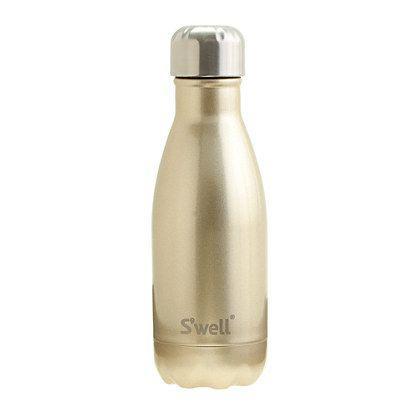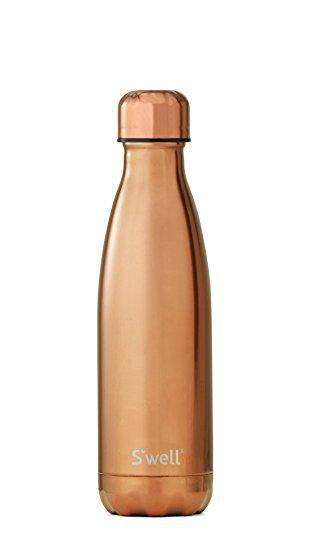The first image is the image on the left, the second image is the image on the right. Examine the images to the left and right. Is the description "the bottle on the left image has a wooden look" accurate? Answer yes or no. No. 